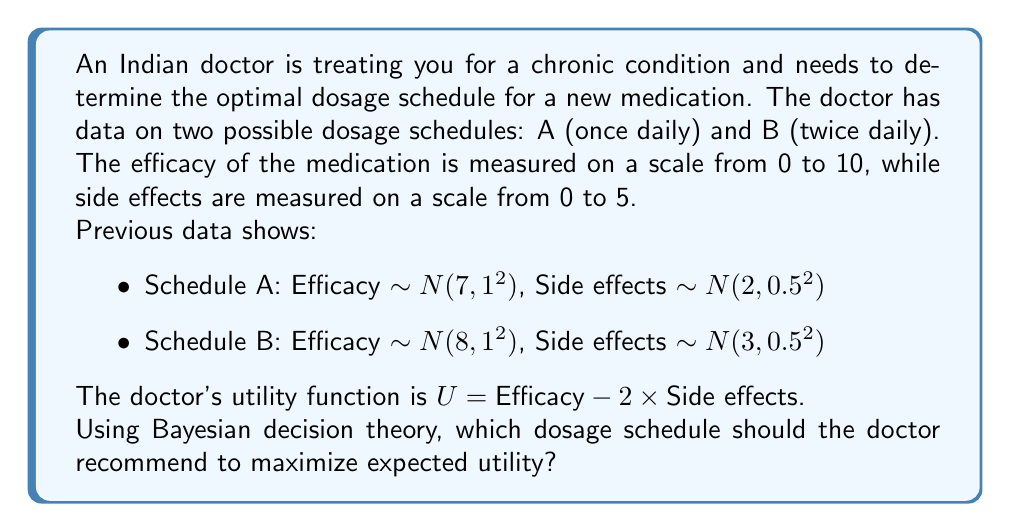Can you solve this math problem? To solve this problem using Bayesian decision theory, we need to calculate the expected utility for each dosage schedule and choose the one with the higher value. Let's break it down step by step:

1. Calculate the expected values for efficacy and side effects for each schedule:

   Schedule A:
   E[Efficacy_A] = 7
   E[Side effects_A] = 2

   Schedule B:
   E[Efficacy_B] = 8
   E[Side effects_B] = 3

2. Apply the utility function U = Efficacy - 2 * Side effects to calculate the expected utility for each schedule:

   Schedule A:
   E[U_A] = E[Efficacy_A] - 2 * E[Side effects_A]
   E[U_A] = 7 - 2 * 2 = 7 - 4 = 3

   Schedule B:
   E[U_B] = E[Efficacy_B] - 2 * E[Side effects_B]
   E[U_B] = 8 - 2 * 3 = 8 - 6 = 2

3. Compare the expected utilities:

   E[U_A] = 3 > E[U_B] = 2

Since the expected utility of Schedule A (3) is greater than the expected utility of Schedule B (2), the doctor should recommend Schedule A to maximize expected utility.

This decision takes into account both the efficacy and side effects of the medication, balancing them according to the given utility function. Schedule A has a lower efficacy but also lower side effects, which results in a higher overall utility when considering the doctor's preference for minimizing side effects (as indicated by the factor of 2 in the utility function).
Answer: The doctor should recommend dosage Schedule A (once daily) to maximize expected utility. 